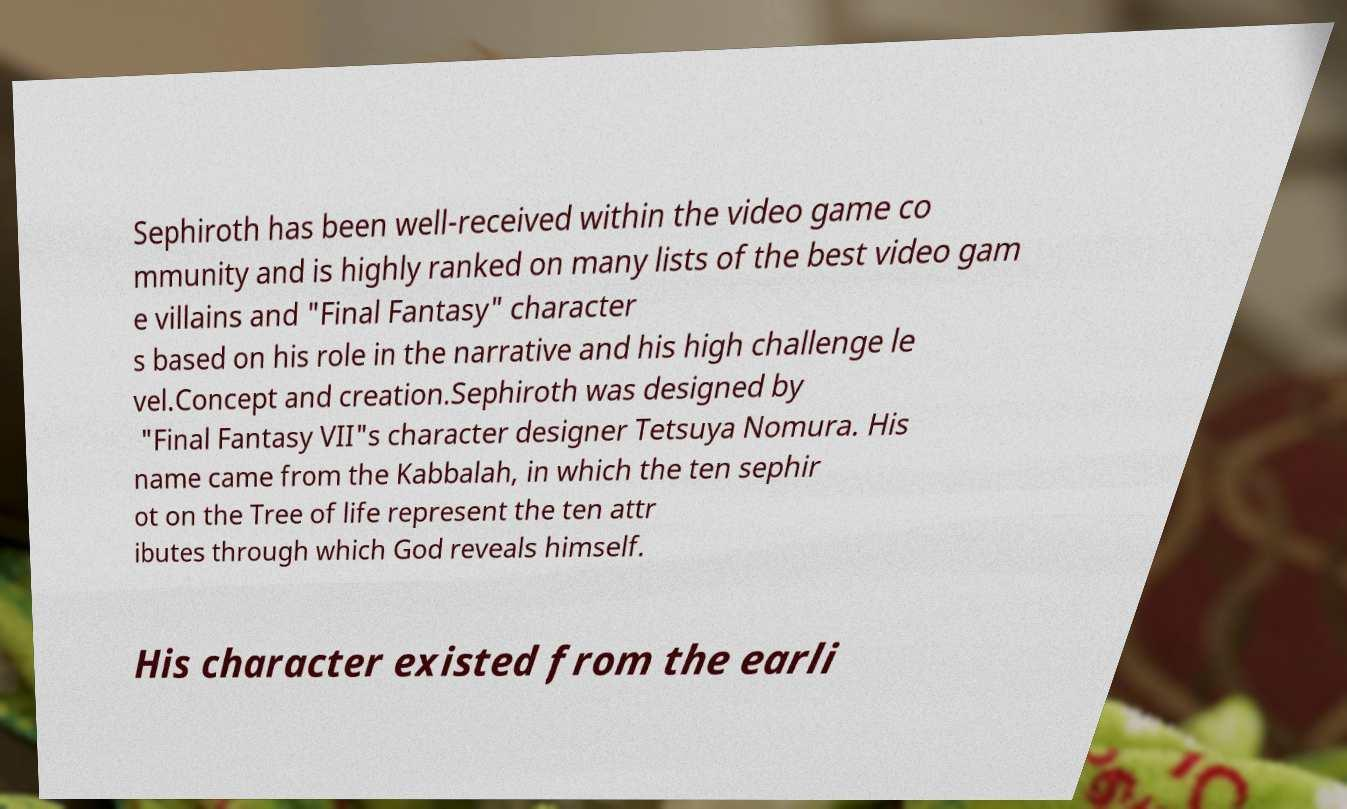Please identify and transcribe the text found in this image. Sephiroth has been well-received within the video game co mmunity and is highly ranked on many lists of the best video gam e villains and "Final Fantasy" character s based on his role in the narrative and his high challenge le vel.Concept and creation.Sephiroth was designed by "Final Fantasy VII"s character designer Tetsuya Nomura. His name came from the Kabbalah, in which the ten sephir ot on the Tree of life represent the ten attr ibutes through which God reveals himself. His character existed from the earli 